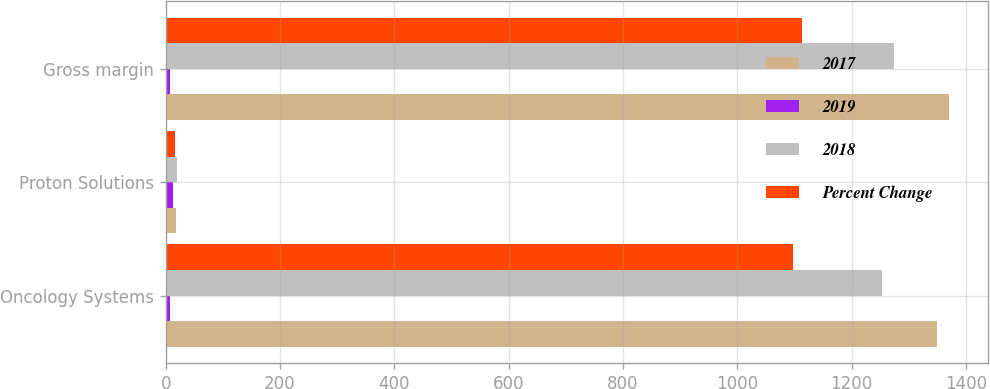Convert chart. <chart><loc_0><loc_0><loc_500><loc_500><stacked_bar_chart><ecel><fcel>Oncology Systems<fcel>Proton Solutions<fcel>Gross margin<nl><fcel>2017<fcel>1349.4<fcel>17.7<fcel>1370.3<nl><fcel>2019<fcel>8<fcel>13<fcel>8<nl><fcel>2018<fcel>1253.2<fcel>20.4<fcel>1273.6<nl><fcel>Percent Change<fcel>1097.9<fcel>16<fcel>1113.9<nl></chart> 